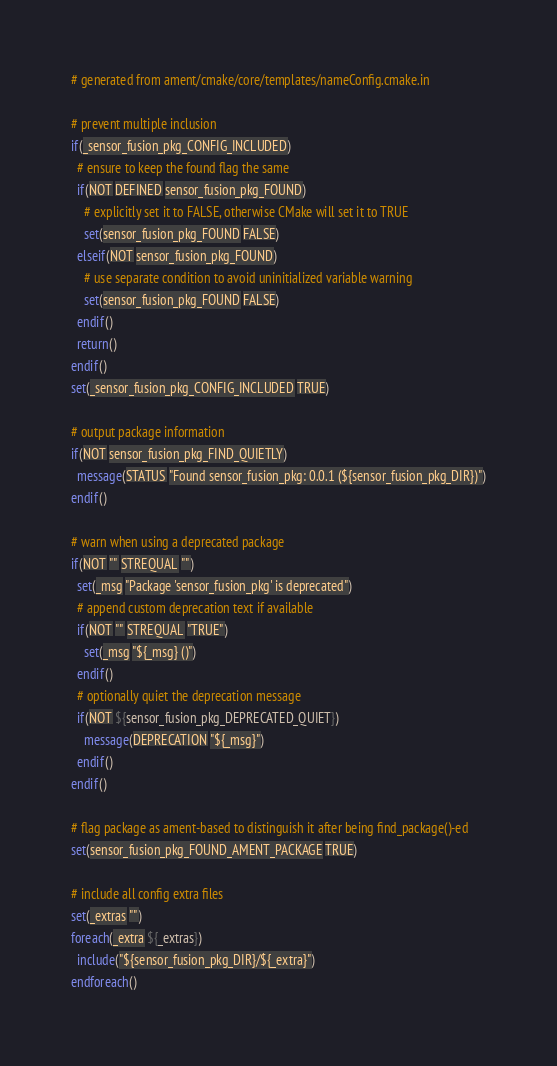<code> <loc_0><loc_0><loc_500><loc_500><_CMake_># generated from ament/cmake/core/templates/nameConfig.cmake.in

# prevent multiple inclusion
if(_sensor_fusion_pkg_CONFIG_INCLUDED)
  # ensure to keep the found flag the same
  if(NOT DEFINED sensor_fusion_pkg_FOUND)
    # explicitly set it to FALSE, otherwise CMake will set it to TRUE
    set(sensor_fusion_pkg_FOUND FALSE)
  elseif(NOT sensor_fusion_pkg_FOUND)
    # use separate condition to avoid uninitialized variable warning
    set(sensor_fusion_pkg_FOUND FALSE)
  endif()
  return()
endif()
set(_sensor_fusion_pkg_CONFIG_INCLUDED TRUE)

# output package information
if(NOT sensor_fusion_pkg_FIND_QUIETLY)
  message(STATUS "Found sensor_fusion_pkg: 0.0.1 (${sensor_fusion_pkg_DIR})")
endif()

# warn when using a deprecated package
if(NOT "" STREQUAL "")
  set(_msg "Package 'sensor_fusion_pkg' is deprecated")
  # append custom deprecation text if available
  if(NOT "" STREQUAL "TRUE")
    set(_msg "${_msg} ()")
  endif()
  # optionally quiet the deprecation message
  if(NOT ${sensor_fusion_pkg_DEPRECATED_QUIET})
    message(DEPRECATION "${_msg}")
  endif()
endif()

# flag package as ament-based to distinguish it after being find_package()-ed
set(sensor_fusion_pkg_FOUND_AMENT_PACKAGE TRUE)

# include all config extra files
set(_extras "")
foreach(_extra ${_extras})
  include("${sensor_fusion_pkg_DIR}/${_extra}")
endforeach()
</code> 